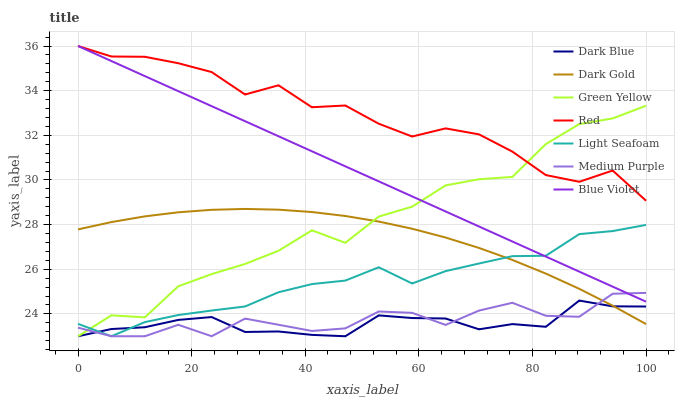Does Dark Gold have the minimum area under the curve?
Answer yes or no. No. Does Dark Gold have the maximum area under the curve?
Answer yes or no. No. Is Dark Gold the smoothest?
Answer yes or no. No. Is Dark Gold the roughest?
Answer yes or no. No. Does Dark Gold have the lowest value?
Answer yes or no. No. Does Dark Gold have the highest value?
Answer yes or no. No. Is Dark Gold less than Blue Violet?
Answer yes or no. Yes. Is Red greater than Medium Purple?
Answer yes or no. Yes. Does Dark Gold intersect Blue Violet?
Answer yes or no. No. 